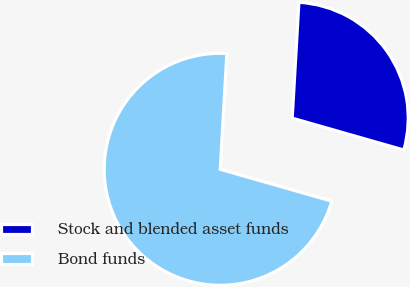Convert chart to OTSL. <chart><loc_0><loc_0><loc_500><loc_500><pie_chart><fcel>Stock and blended asset funds<fcel>Bond funds<nl><fcel>28.51%<fcel>71.49%<nl></chart> 